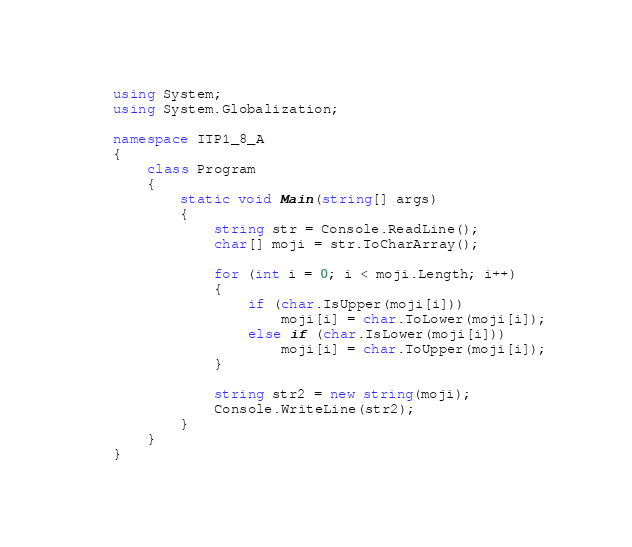Convert code to text. <code><loc_0><loc_0><loc_500><loc_500><_C#_>using System;
using System.Globalization;

namespace ITP1_8_A
{
    class Program
    {
        static void Main(string[] args)
        {
            string str = Console.ReadLine();
            char[] moji = str.ToCharArray();

            for (int i = 0; i < moji.Length; i++)
            {
                if (char.IsUpper(moji[i]))
                    moji[i] = char.ToLower(moji[i]);
                else if (char.IsLower(moji[i]))
                    moji[i] = char.ToUpper(moji[i]);
            }

            string str2 = new string(moji);
            Console.WriteLine(str2);
        }
    }
}

</code> 